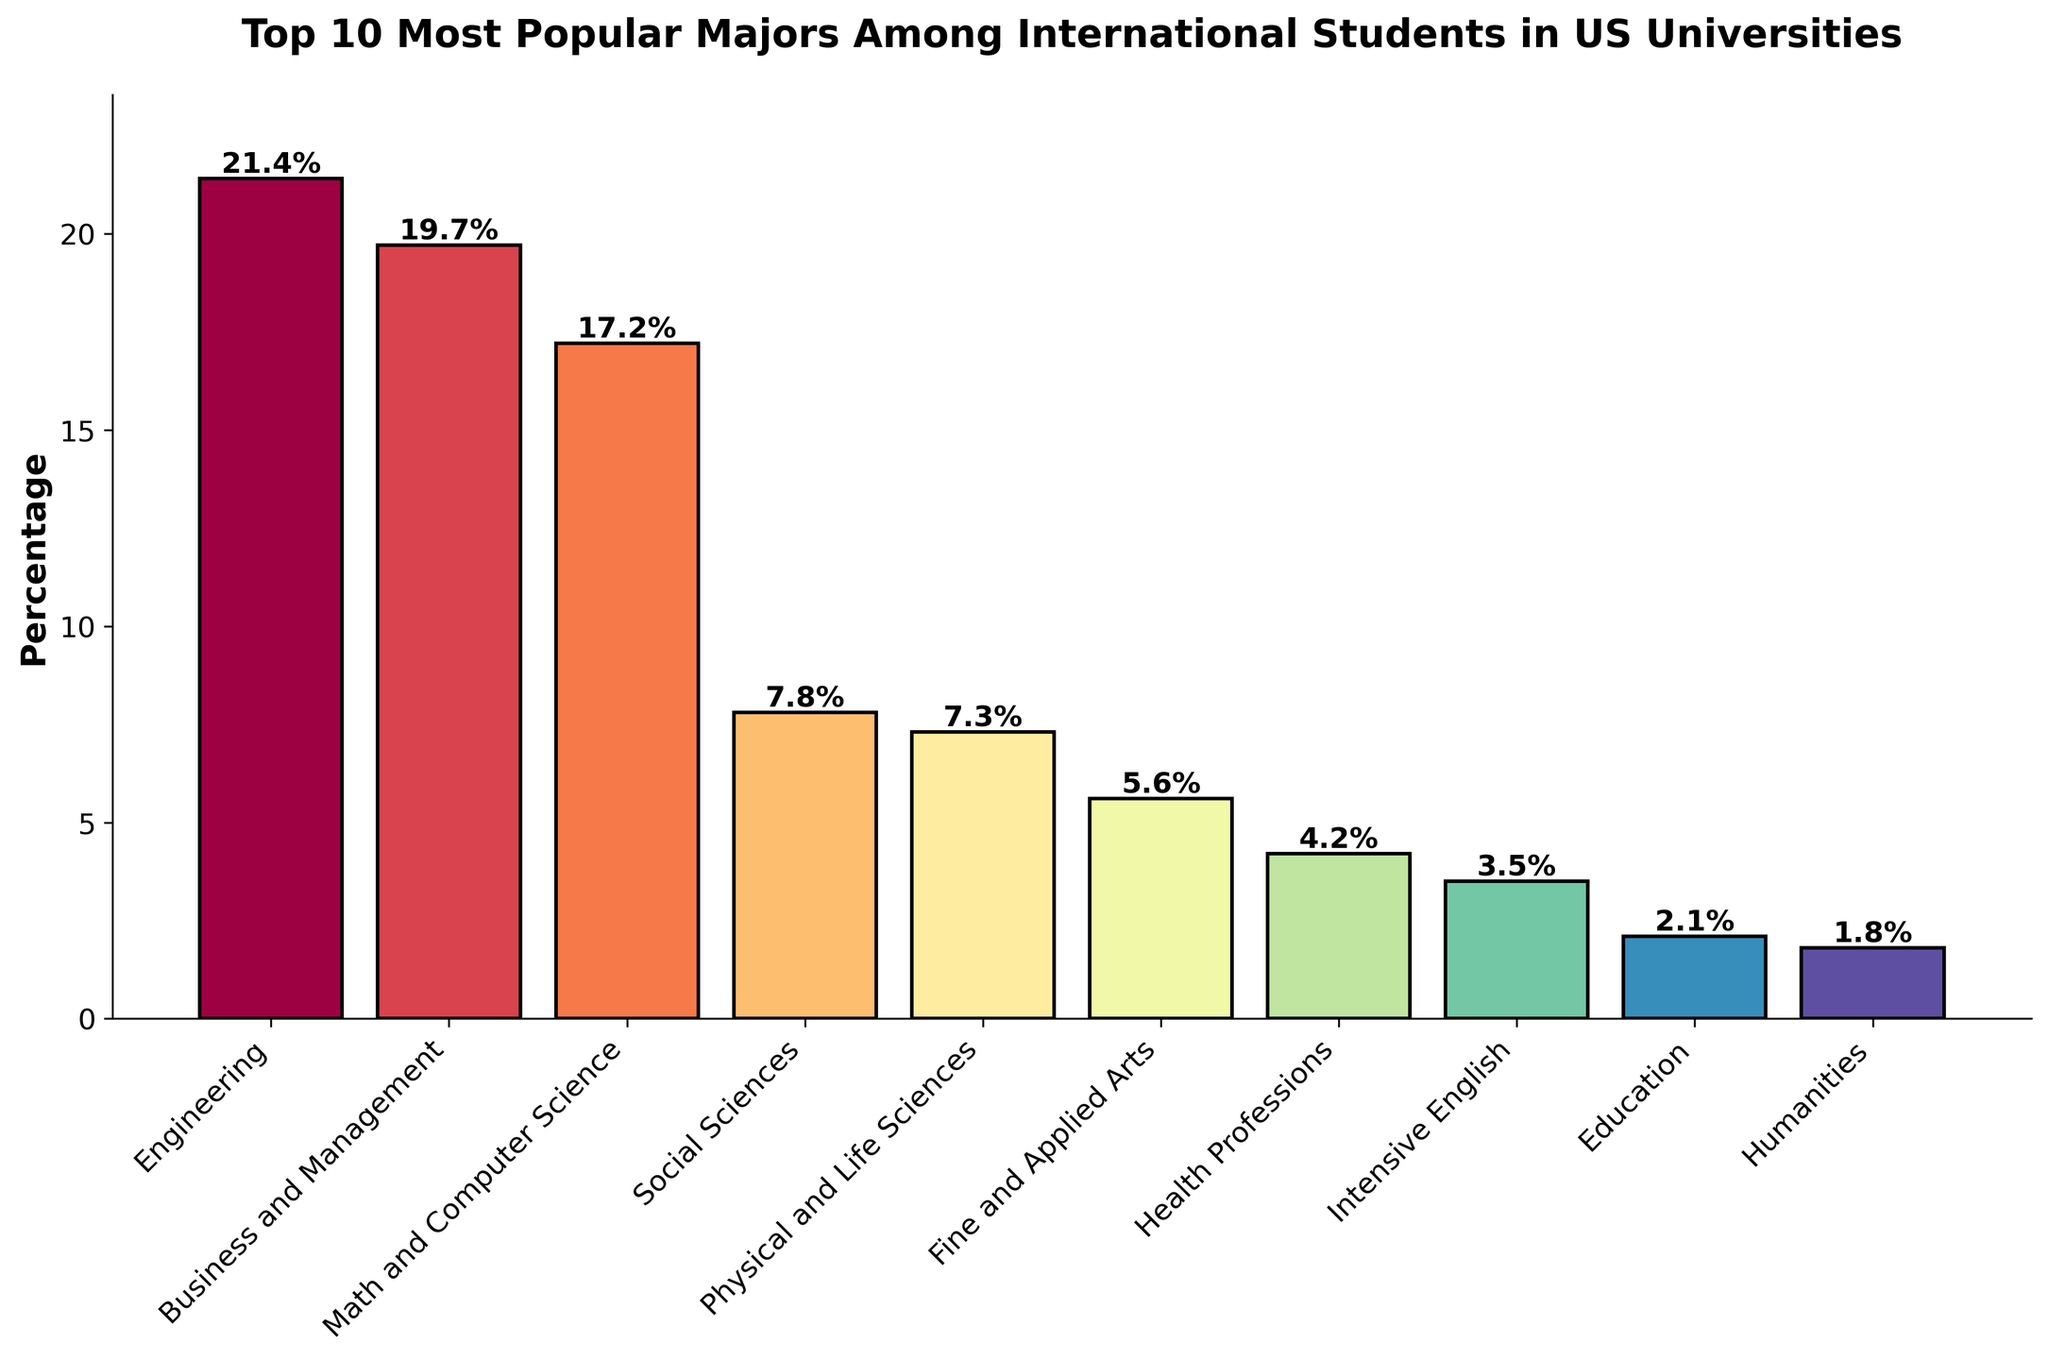What major has the highest percentage among international students in US universities? The figure shows the percentages for each major. The bar for Engineering is the tallest, indicating it has the highest percentage.
Answer: Engineering Which two majors have the most similar percentages? By looking at the heights of the bars, Business and Management and Math and Computer Science have percentages that are very close to each other (19.7% and 17.2% respectively).
Answer: Business and Management and Math and Computer Science What is the total percentage of international students in Engineering, Business and Management, and Math and Computer Science majors combined? Add the percentages for Engineering (21.4%), Business and Management (19.7%), and Math and Computer Science (17.2%). The total is 21.4 + 19.7 + 17.2 = 58.3%.
Answer: 58.3% Which major has a lower percentage: Social Sciences or Physical and Life Sciences? Compare the heights of the bars for Social Sciences (7.8%) and Physical and Life Sciences (7.3%). Social Sciences has a higher percentage.
Answer: Physical and Life Sciences What is the difference in percentage between the most popular and least popular majors? Subtract the percentage of the least popular major (Humanities, 1.8%) from the most popular major (Engineering, 21.4%). The difference is 21.4 - 1.8 = 19.6%.
Answer: 19.6% How much larger is the percentage of Business and Management compared to Health Professions? Subtract the percentage of Health Professions (4.2%) from Business and Management (19.7%). The difference is 19.7 - 4.2 = 15.5%.
Answer: 15.5% Are there any majors with a percentage lower than 3%? If so, which ones? From the chart, look for bars that have percentages less than 3%. Only Humanities (1.8%) and Education (2.1%) fit this criterion.
Answer: Humanities and Education Which major falls in the middle in terms of popularity? Since there are 10 majors, the 5th and 6th ranked majors will be in the middle. By ordering the percentages, the middle majors are Physical and Life Sciences (7.3%) and Fine and Applied Arts (5.6%).
Answer: Physical and Life Sciences and Fine and Applied Arts How do the percentages of Intensive English and Fine and Applied Arts compare? Compare the heights of their bars; Fine and Applied Arts is 5.6% and Intensive English is 3.5%. Fine and Applied Arts has a higher percentage.
Answer: Fine and Applied Arts 